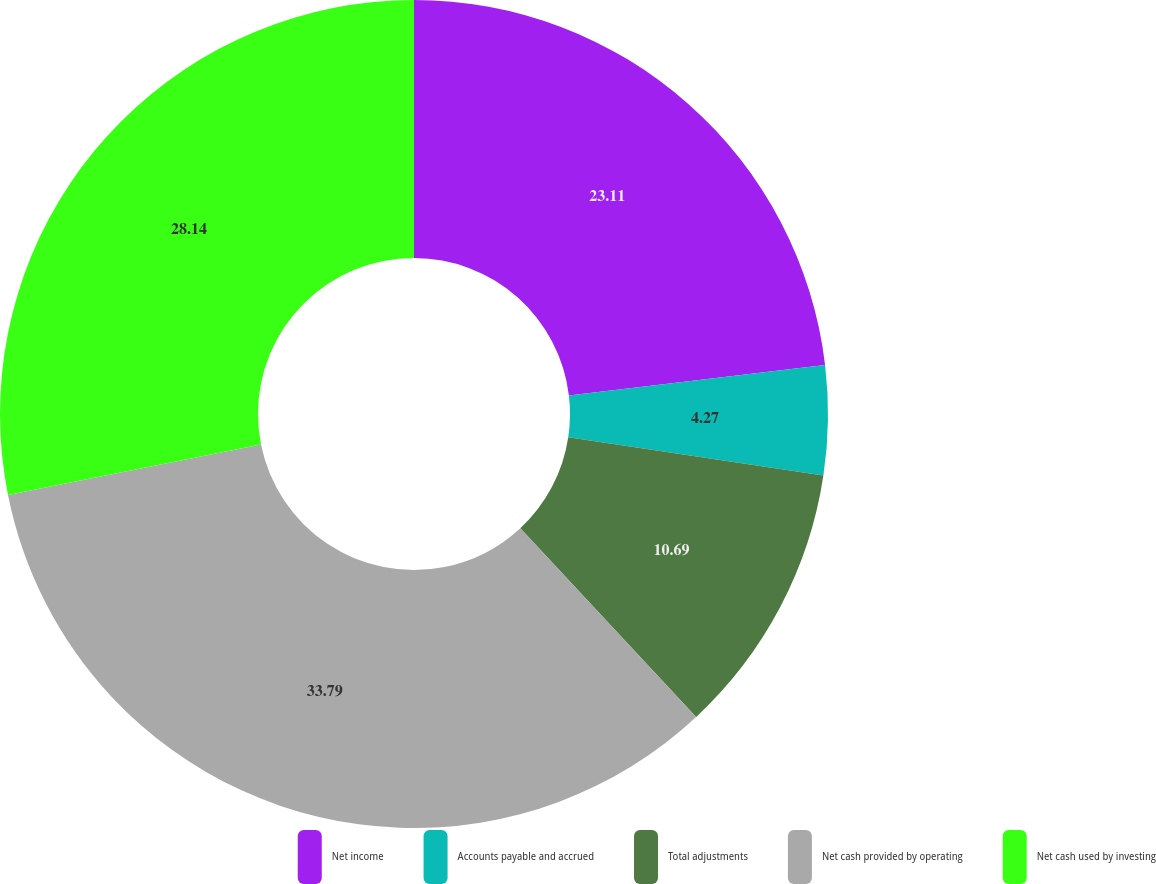Convert chart. <chart><loc_0><loc_0><loc_500><loc_500><pie_chart><fcel>Net income<fcel>Accounts payable and accrued<fcel>Total adjustments<fcel>Net cash provided by operating<fcel>Net cash used by investing<nl><fcel>23.11%<fcel>4.27%<fcel>10.69%<fcel>33.8%<fcel>28.14%<nl></chart> 